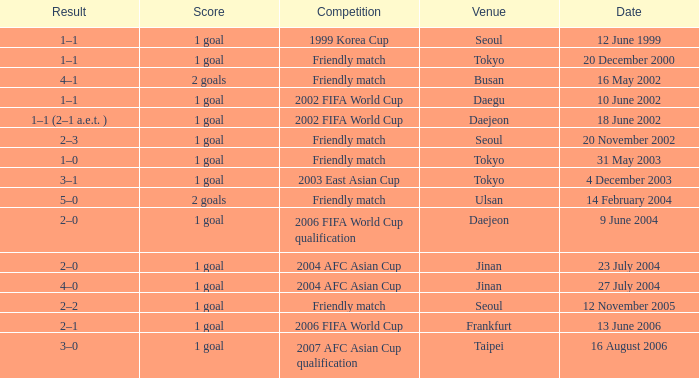What is the venue for the event on 12 November 2005? Seoul. 